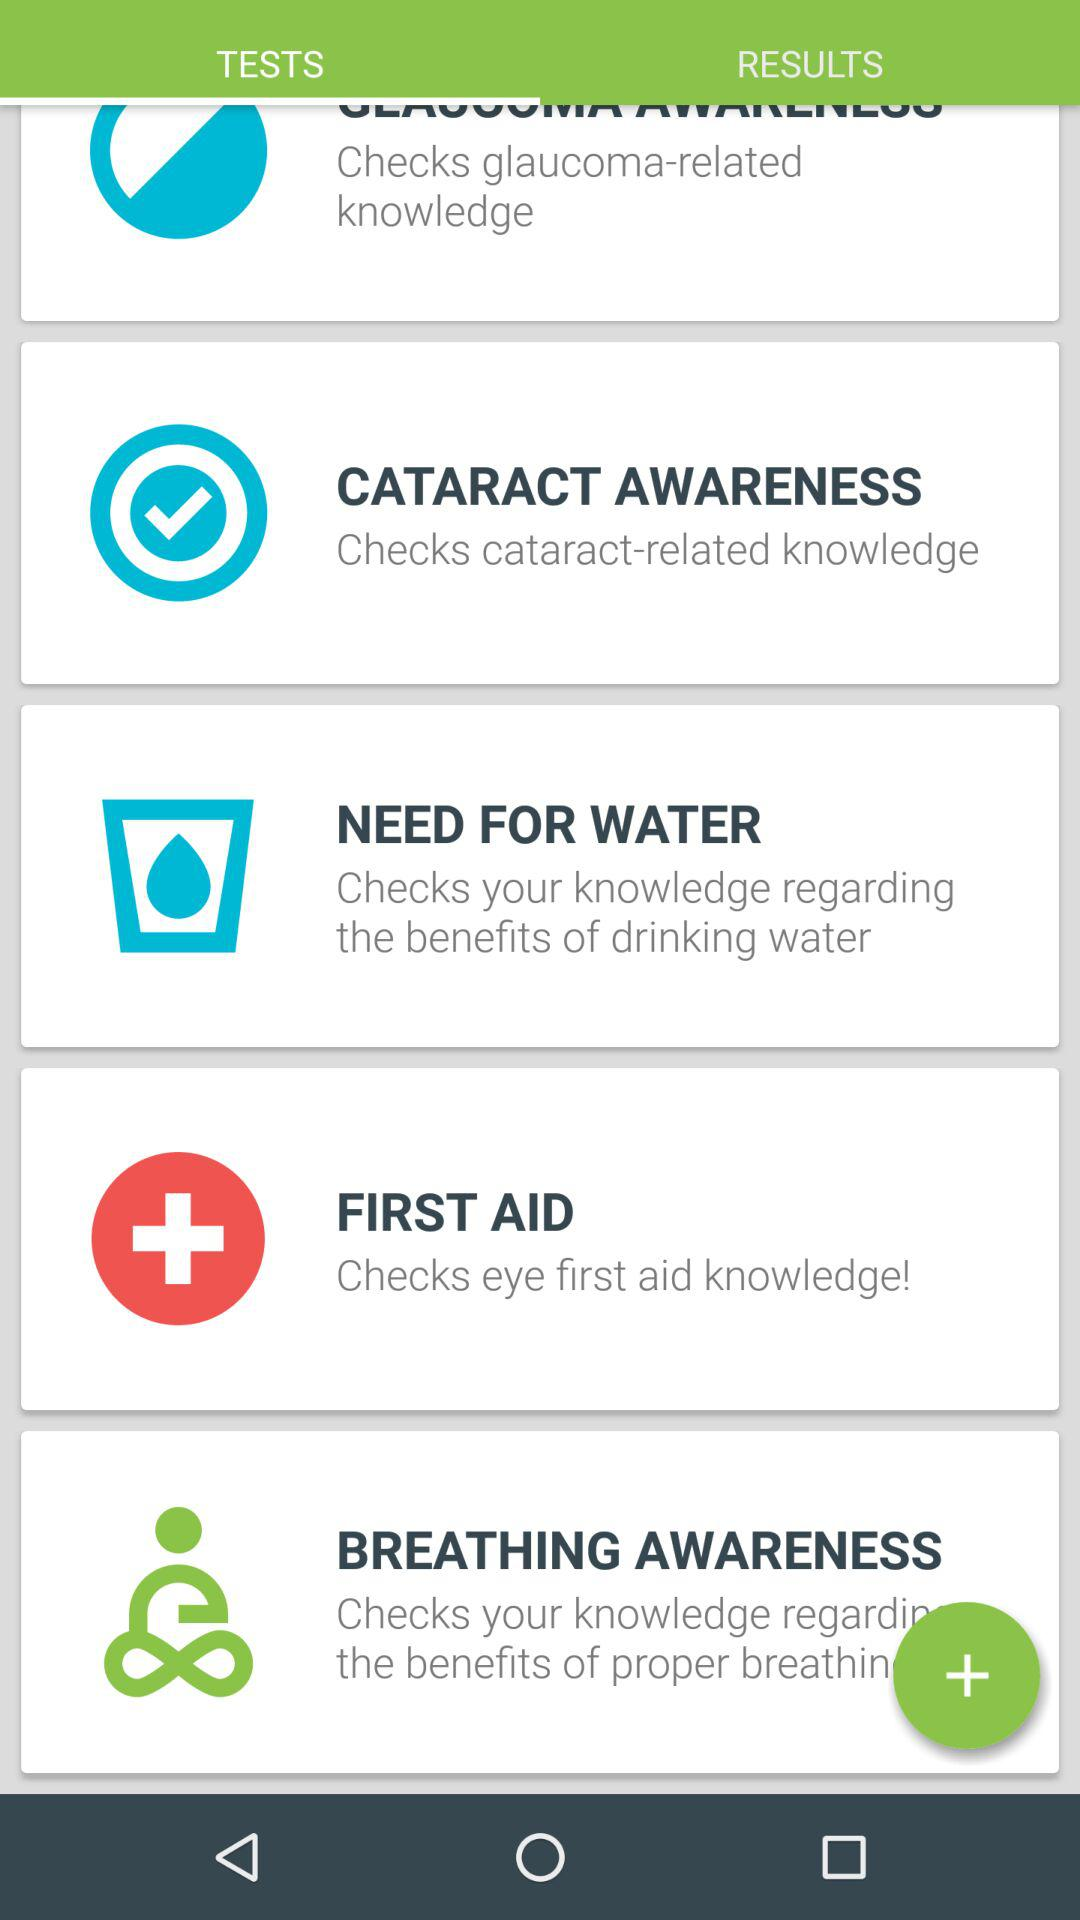How many tests are related to eye health?
Answer the question using a single word or phrase. 3 